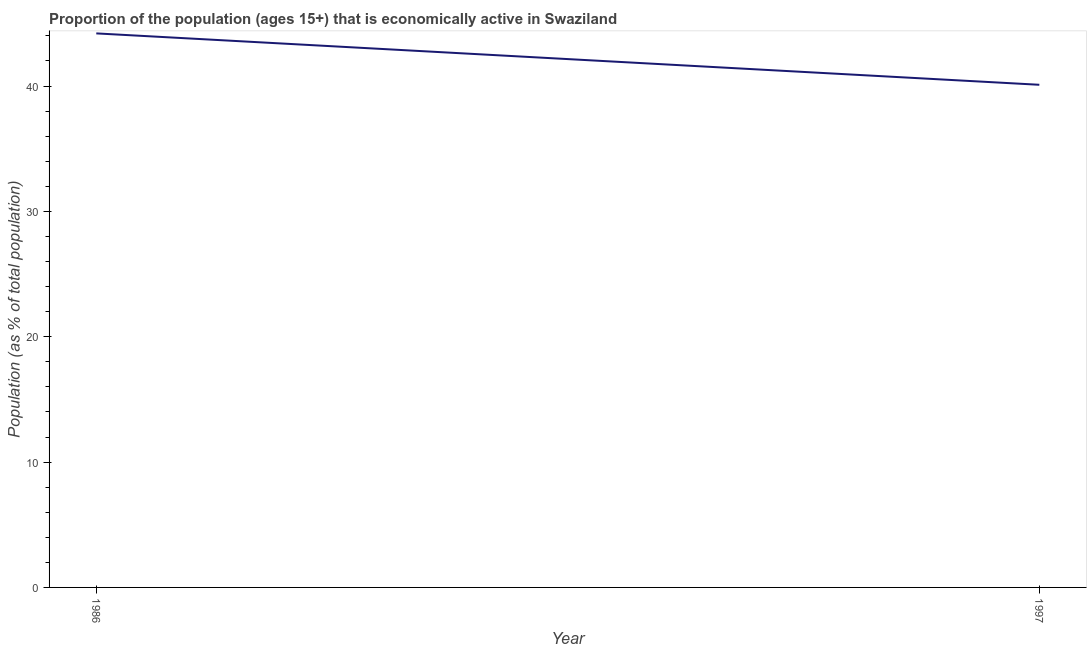What is the percentage of economically active population in 1986?
Your response must be concise. 44.2. Across all years, what is the maximum percentage of economically active population?
Give a very brief answer. 44.2. Across all years, what is the minimum percentage of economically active population?
Ensure brevity in your answer.  40.1. In which year was the percentage of economically active population maximum?
Offer a terse response. 1986. What is the sum of the percentage of economically active population?
Ensure brevity in your answer.  84.3. What is the difference between the percentage of economically active population in 1986 and 1997?
Provide a short and direct response. 4.1. What is the average percentage of economically active population per year?
Ensure brevity in your answer.  42.15. What is the median percentage of economically active population?
Ensure brevity in your answer.  42.15. What is the ratio of the percentage of economically active population in 1986 to that in 1997?
Ensure brevity in your answer.  1.1. In how many years, is the percentage of economically active population greater than the average percentage of economically active population taken over all years?
Provide a short and direct response. 1. Does the percentage of economically active population monotonically increase over the years?
Give a very brief answer. No. Are the values on the major ticks of Y-axis written in scientific E-notation?
Offer a very short reply. No. Does the graph contain grids?
Provide a short and direct response. No. What is the title of the graph?
Provide a succinct answer. Proportion of the population (ages 15+) that is economically active in Swaziland. What is the label or title of the X-axis?
Your response must be concise. Year. What is the label or title of the Y-axis?
Offer a very short reply. Population (as % of total population). What is the Population (as % of total population) of 1986?
Give a very brief answer. 44.2. What is the Population (as % of total population) in 1997?
Your response must be concise. 40.1. What is the ratio of the Population (as % of total population) in 1986 to that in 1997?
Give a very brief answer. 1.1. 